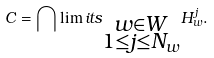Convert formula to latex. <formula><loc_0><loc_0><loc_500><loc_500>\label l { f i n i t e i n t e r s e c t i o n } C = \bigcap \lim i t s _ { \substack { w \in W \\ 1 \leq j \leq N _ { w } } } H _ { w } ^ { j } .</formula> 